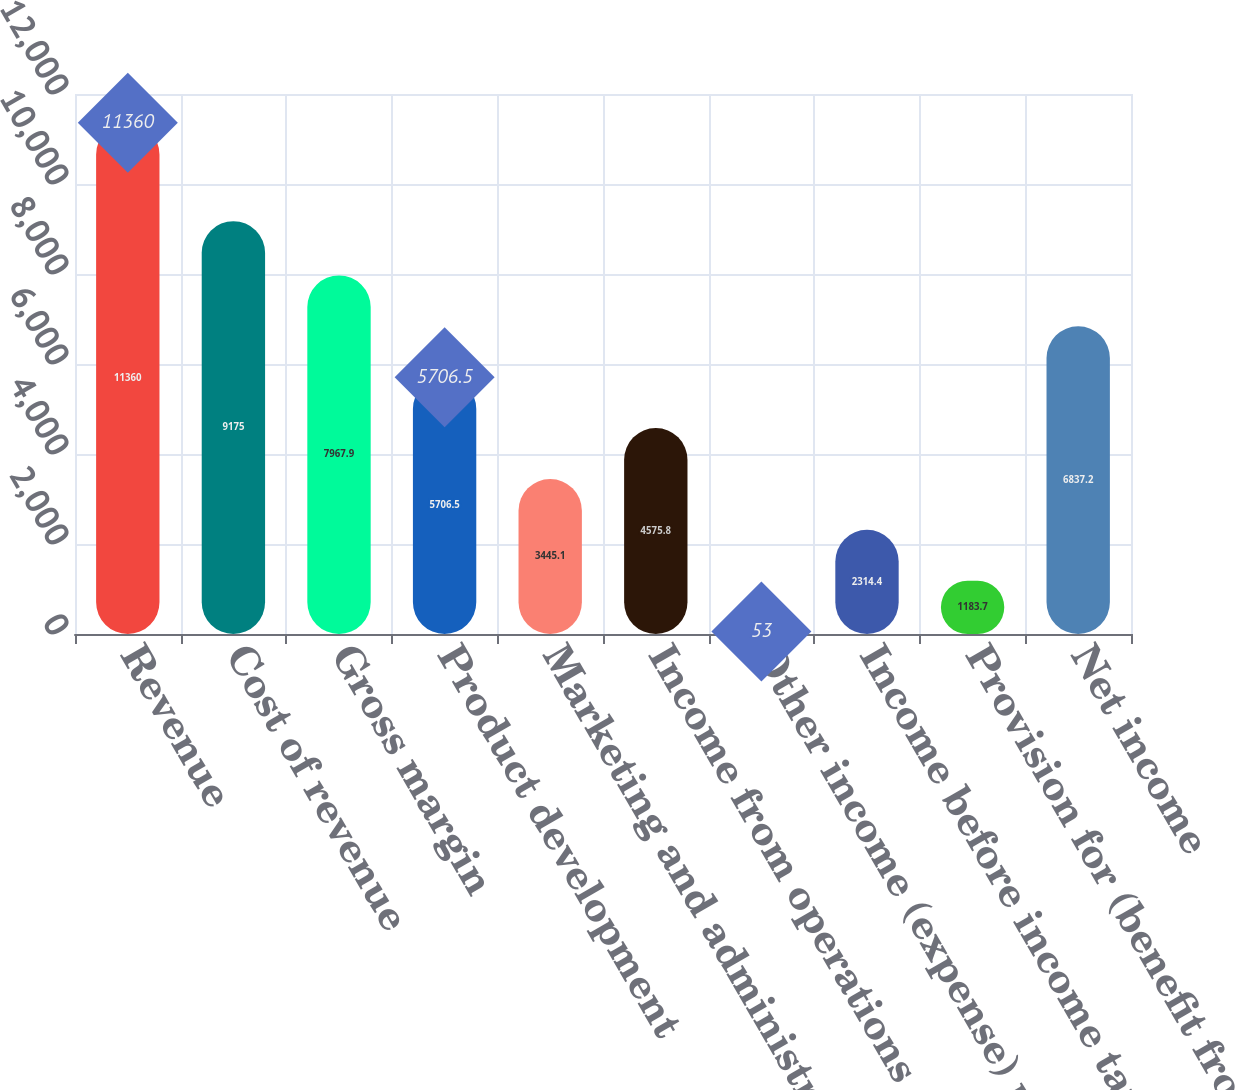Convert chart. <chart><loc_0><loc_0><loc_500><loc_500><bar_chart><fcel>Revenue<fcel>Cost of revenue<fcel>Gross margin<fcel>Product development<fcel>Marketing and administrative<fcel>Income from operations<fcel>Other income (expense) net<fcel>Income before income taxes<fcel>Provision for (benefit from)<fcel>Net income<nl><fcel>11360<fcel>9175<fcel>7967.9<fcel>5706.5<fcel>3445.1<fcel>4575.8<fcel>53<fcel>2314.4<fcel>1183.7<fcel>6837.2<nl></chart> 